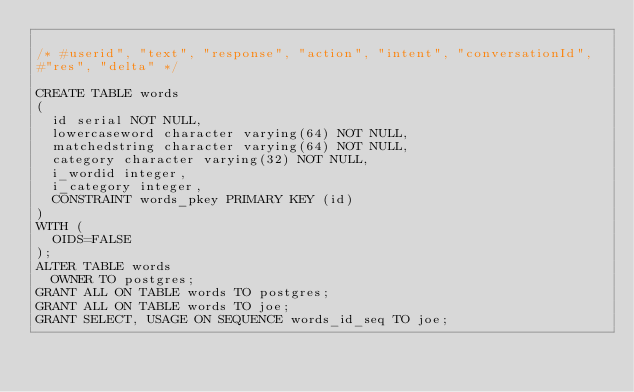<code> <loc_0><loc_0><loc_500><loc_500><_SQL_>
/* #userid", "text", "response", "action", "intent", "conversationId",
#"res", "delta" */

CREATE TABLE words
(
  id serial NOT NULL,
  lowercaseword character varying(64) NOT NULL,
  matchedstring character varying(64) NOT NULL,
  category character varying(32) NOT NULL,
  i_wordid integer,
  i_category integer,
  CONSTRAINT words_pkey PRIMARY KEY (id)
)
WITH (
  OIDS=FALSE
);
ALTER TABLE words
  OWNER TO postgres;
GRANT ALL ON TABLE words TO postgres;
GRANT ALL ON TABLE words TO joe;
GRANT SELECT, USAGE ON SEQUENCE words_id_seq TO joe;
</code> 